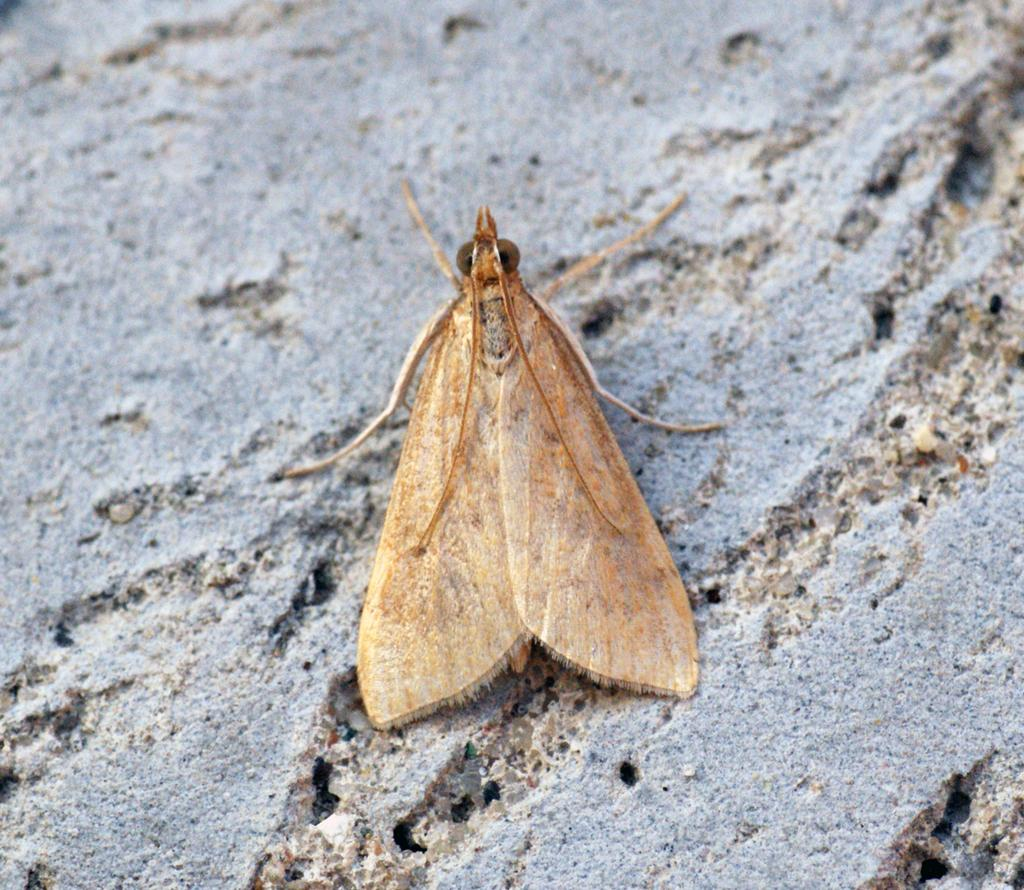What type of insect is visible in the image? There is a moth visible in the image. Can you describe the moth's location in the image? The moth may be on a rock in the image. What type of trains can be seen passing by in the image? There are no trains visible in the image; it features a moth that may be on a rock. 